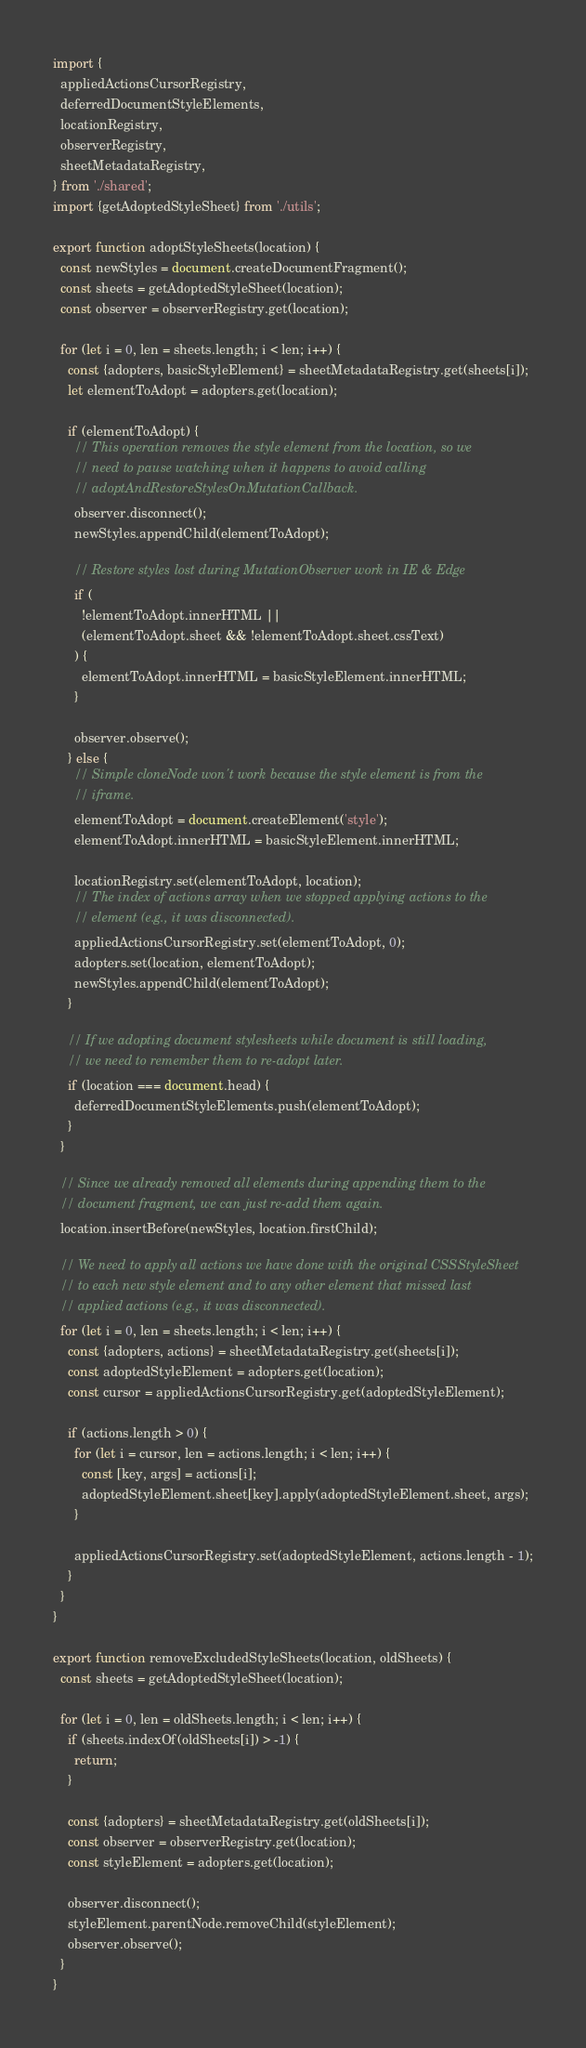<code> <loc_0><loc_0><loc_500><loc_500><_JavaScript_>import {
  appliedActionsCursorRegistry,
  deferredDocumentStyleElements,
  locationRegistry,
  observerRegistry,
  sheetMetadataRegistry,
} from './shared';
import {getAdoptedStyleSheet} from './utils';

export function adoptStyleSheets(location) {
  const newStyles = document.createDocumentFragment();
  const sheets = getAdoptedStyleSheet(location);
  const observer = observerRegistry.get(location);

  for (let i = 0, len = sheets.length; i < len; i++) {
    const {adopters, basicStyleElement} = sheetMetadataRegistry.get(sheets[i]);
    let elementToAdopt = adopters.get(location);

    if (elementToAdopt) {
      // This operation removes the style element from the location, so we
      // need to pause watching when it happens to avoid calling
      // adoptAndRestoreStylesOnMutationCallback.
      observer.disconnect();
      newStyles.appendChild(elementToAdopt);

      // Restore styles lost during MutationObserver work in IE & Edge
      if (
        !elementToAdopt.innerHTML ||
        (elementToAdopt.sheet && !elementToAdopt.sheet.cssText)
      ) {
        elementToAdopt.innerHTML = basicStyleElement.innerHTML;
      }

      observer.observe();
    } else {
      // Simple cloneNode won't work because the style element is from the
      // iframe.
      elementToAdopt = document.createElement('style');
      elementToAdopt.innerHTML = basicStyleElement.innerHTML;

      locationRegistry.set(elementToAdopt, location);
      // The index of actions array when we stopped applying actions to the
      // element (e.g., it was disconnected).
      appliedActionsCursorRegistry.set(elementToAdopt, 0);
      adopters.set(location, elementToAdopt);
      newStyles.appendChild(elementToAdopt);
    }

    // If we adopting document stylesheets while document is still loading,
    // we need to remember them to re-adopt later.
    if (location === document.head) {
      deferredDocumentStyleElements.push(elementToAdopt);
    }
  }

  // Since we already removed all elements during appending them to the
  // document fragment, we can just re-add them again.
  location.insertBefore(newStyles, location.firstChild);

  // We need to apply all actions we have done with the original CSSStyleSheet
  // to each new style element and to any other element that missed last
  // applied actions (e.g., it was disconnected).
  for (let i = 0, len = sheets.length; i < len; i++) {
    const {adopters, actions} = sheetMetadataRegistry.get(sheets[i]);
    const adoptedStyleElement = adopters.get(location);
    const cursor = appliedActionsCursorRegistry.get(adoptedStyleElement);

    if (actions.length > 0) {
      for (let i = cursor, len = actions.length; i < len; i++) {
        const [key, args] = actions[i];
        adoptedStyleElement.sheet[key].apply(adoptedStyleElement.sheet, args);
      }

      appliedActionsCursorRegistry.set(adoptedStyleElement, actions.length - 1);
    }
  }
}

export function removeExcludedStyleSheets(location, oldSheets) {
  const sheets = getAdoptedStyleSheet(location);

  for (let i = 0, len = oldSheets.length; i < len; i++) {
    if (sheets.indexOf(oldSheets[i]) > -1) {
      return;
    }

    const {adopters} = sheetMetadataRegistry.get(oldSheets[i]);
    const observer = observerRegistry.get(location);
    const styleElement = adopters.get(location);

    observer.disconnect();
    styleElement.parentNode.removeChild(styleElement);
    observer.observe();
  }
}
</code> 